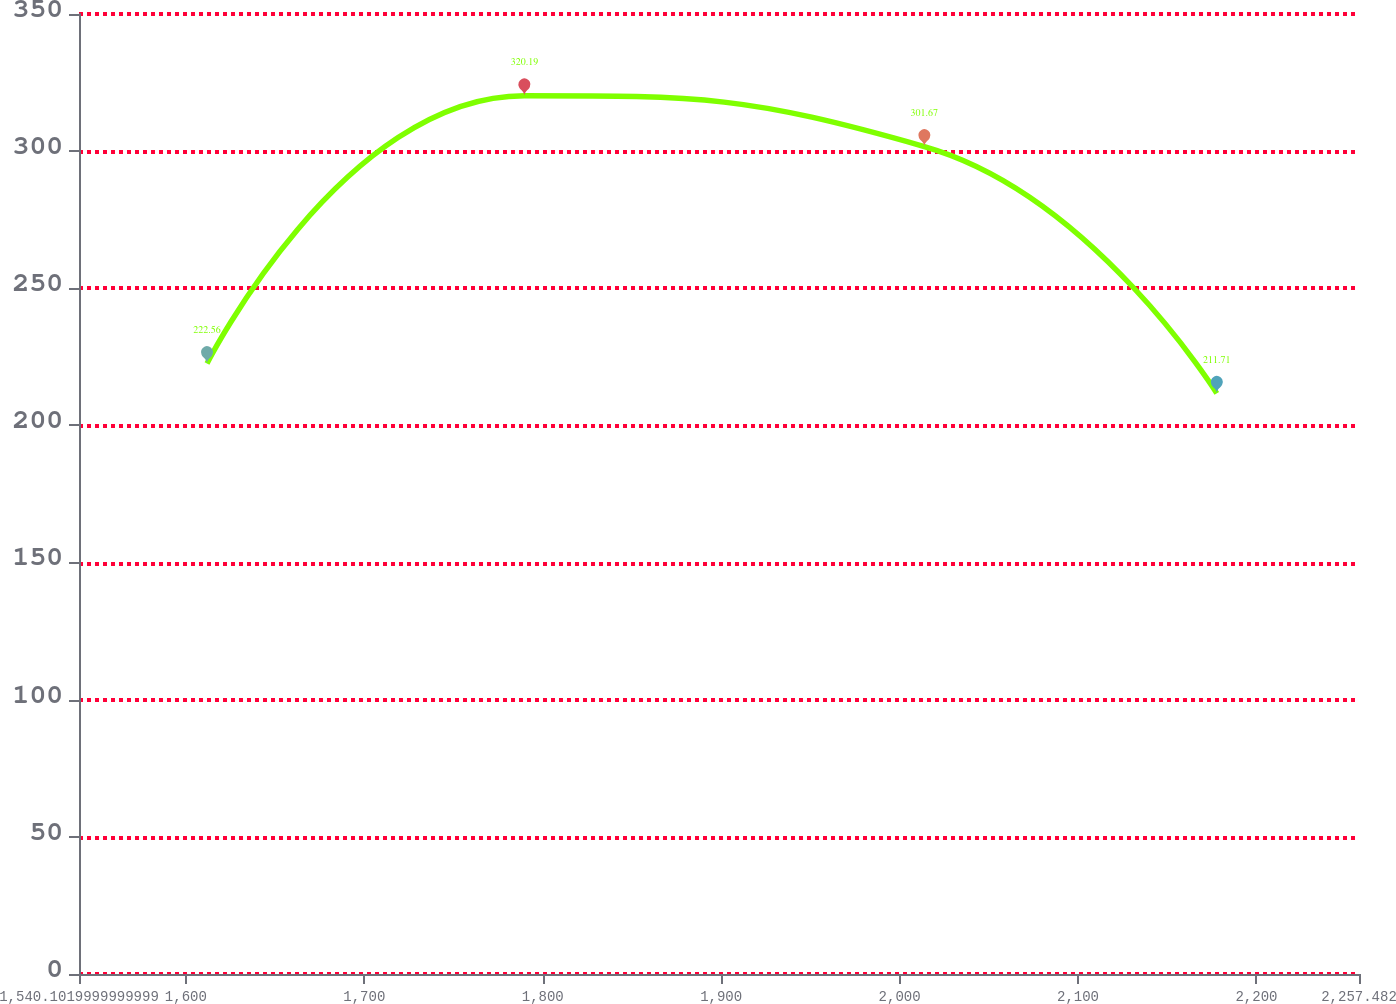Convert chart to OTSL. <chart><loc_0><loc_0><loc_500><loc_500><line_chart><ecel><fcel>Unnamed: 1<nl><fcel>1611.84<fcel>222.56<nl><fcel>1789.73<fcel>320.19<nl><fcel>2013.89<fcel>301.67<nl><fcel>2177.78<fcel>211.71<nl><fcel>2329.22<fcel>233.41<nl></chart> 